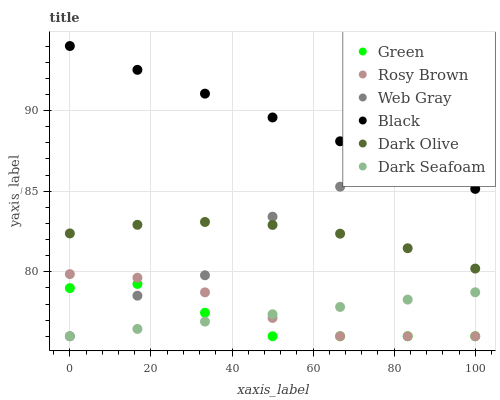Does Green have the minimum area under the curve?
Answer yes or no. Yes. Does Black have the maximum area under the curve?
Answer yes or no. Yes. Does Dark Olive have the minimum area under the curve?
Answer yes or no. No. Does Dark Olive have the maximum area under the curve?
Answer yes or no. No. Is Dark Seafoam the smoothest?
Answer yes or no. Yes. Is Web Gray the roughest?
Answer yes or no. Yes. Is Dark Olive the smoothest?
Answer yes or no. No. Is Dark Olive the roughest?
Answer yes or no. No. Does Web Gray have the lowest value?
Answer yes or no. Yes. Does Dark Olive have the lowest value?
Answer yes or no. No. Does Black have the highest value?
Answer yes or no. Yes. Does Dark Olive have the highest value?
Answer yes or no. No. Is Rosy Brown less than Dark Olive?
Answer yes or no. Yes. Is Black greater than Green?
Answer yes or no. Yes. Does Green intersect Rosy Brown?
Answer yes or no. Yes. Is Green less than Rosy Brown?
Answer yes or no. No. Is Green greater than Rosy Brown?
Answer yes or no. No. Does Rosy Brown intersect Dark Olive?
Answer yes or no. No. 